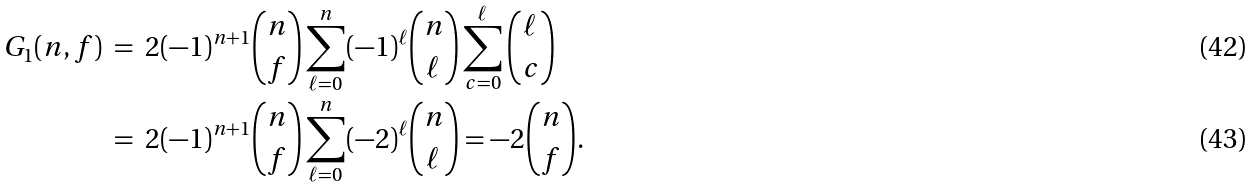Convert formula to latex. <formula><loc_0><loc_0><loc_500><loc_500>G _ { 1 } ( n , f ) \ & = \ 2 ( - 1 ) ^ { n + 1 } \binom { n } { f } \sum _ { \ell = 0 } ^ { n } ( - 1 ) ^ { \ell } \binom { n } { \ell } \sum _ { c = 0 } ^ { \ell } \binom { \ell } { c } \\ & = \ 2 ( - 1 ) ^ { n + 1 } \binom { n } { f } \sum _ { \ell = 0 } ^ { n } ( - 2 ) ^ { \ell } \binom { n } { \ell } = - 2 \binom { n } { f } .</formula> 